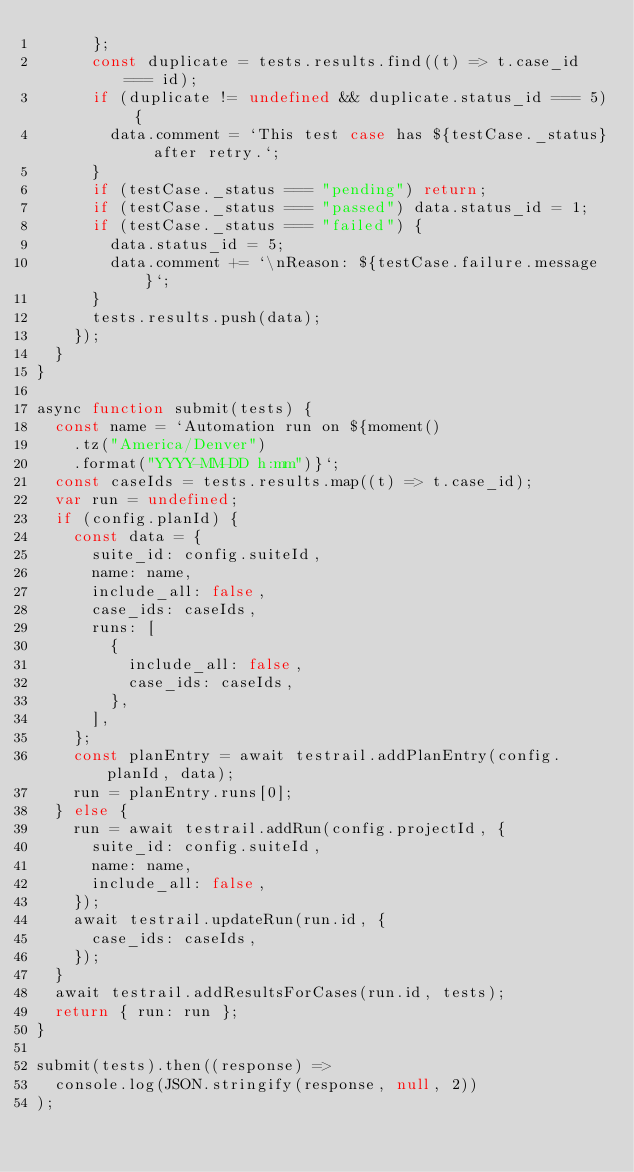Convert code to text. <code><loc_0><loc_0><loc_500><loc_500><_JavaScript_>      };
      const duplicate = tests.results.find((t) => t.case_id === id);
      if (duplicate != undefined && duplicate.status_id === 5) {
        data.comment = `This test case has ${testCase._status} after retry.`;
      }
      if (testCase._status === "pending") return;
      if (testCase._status === "passed") data.status_id = 1;
      if (testCase._status === "failed") {
        data.status_id = 5;
        data.comment += `\nReason: ${testCase.failure.message}`;
      }
      tests.results.push(data);
    });
  }
}

async function submit(tests) {
  const name = `Automation run on ${moment()
    .tz("America/Denver")
    .format("YYYY-MM-DD h:mm")}`;
  const caseIds = tests.results.map((t) => t.case_id);
  var run = undefined;
  if (config.planId) {
    const data = {
      suite_id: config.suiteId,
      name: name,
      include_all: false,
      case_ids: caseIds,
      runs: [
        {
          include_all: false,
          case_ids: caseIds,
        },
      ],
    };
    const planEntry = await testrail.addPlanEntry(config.planId, data);
    run = planEntry.runs[0];
  } else {
    run = await testrail.addRun(config.projectId, {
      suite_id: config.suiteId,
      name: name,
      include_all: false,
    });
    await testrail.updateRun(run.id, {
      case_ids: caseIds,
    });
  }
  await testrail.addResultsForCases(run.id, tests);
  return { run: run };
}

submit(tests).then((response) =>
  console.log(JSON.stringify(response, null, 2))
);
</code> 